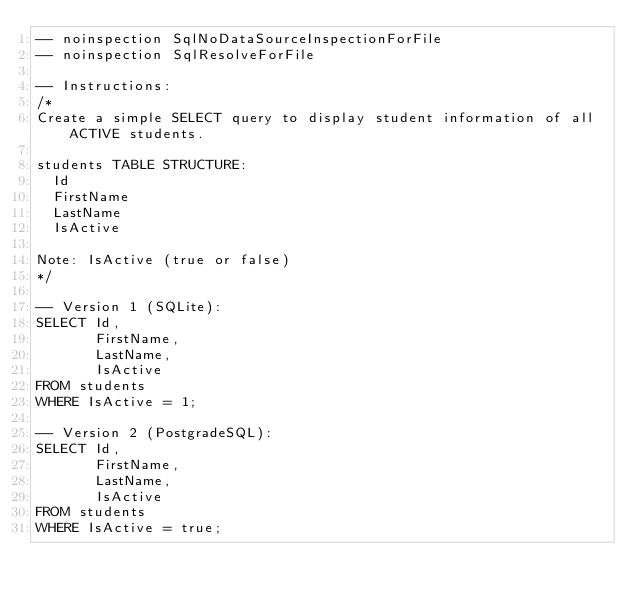<code> <loc_0><loc_0><loc_500><loc_500><_SQL_>-- noinspection SqlNoDataSourceInspectionForFile
-- noinspection SqlResolveForFile

-- Instructions:
/*
Create a simple SELECT query to display student information of all ACTIVE students.

students TABLE STRUCTURE:
  Id
  FirstName
  LastName
  IsActive

Note: IsActive (true or false)
*/

-- Version 1 (SQLite):
SELECT Id,
       FirstName,
       LastName,
       IsActive
FROM students
WHERE IsActive = 1;

-- Version 2 (PostgradeSQL):
SELECT Id,
       FirstName,
       LastName,
       IsActive
FROM students
WHERE IsActive = true;</code> 